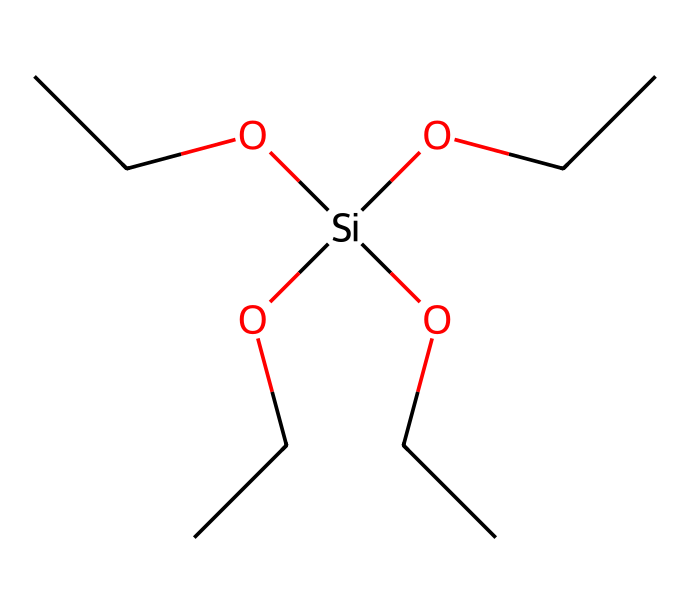What is the molecular formula of tetraethoxysilane? The molecular formula can be determined by counting the number of each type of atom present in the chemical structure. In the SMILES representation, there are 8 carbon atoms (C), 20 hydrogen atoms (H), 4 oxygen atoms (O), and 1 silicon atom (Si). This results in the formula C8H20O4Si.
Answer: C8H20O4Si How many ethoxy groups are present in tetraethoxysilane? The chemical structure shows that there are four ethoxy groups (–OCC) attached to the silicon atom. Each ethoxy group consists of two carbon atoms, so we confirm that there are four of them associated with the silicon.
Answer: 4 What functional groups are present in tetraethoxysilane? In the chemical structure, the prominent functional groups are the ethoxy groups (–OCC) and the silanol group, indicated by the presence of the silicon atom bonded to oxygen. The presence of oxygen atoms in these groups identifies them as functional groups.
Answer: ethoxy, silanol What is the primary element that characterizes silanes? Silanes are defined by the presence of silicon atoms, which are central to their structure. The Silicon atom’s connectivity to organic groups (like the ethoxy in this case) is key to classifying a compound as a silane.
Answer: silicon How many hydrogen atoms are bonded to the silicon in tetraethoxysilane? In the given structure, all four ethoxy groups are attached to the silicon atom, meaning it has no hydrogen atoms directly bonded to it. The compounds attached account for all valences filled. Thus, there are no hydrogen atoms directly bonded to the silicon.
Answer: 0 What distinguishes tetraethoxysilane from other silanes regarding its solubility? Tetraethoxysilane has ethoxy groups, which are hydrophilic in nature. This characteristic makes it more soluble in organic solvents compared to silanes that consist mostly of hydrophobic groups, enhancing its utility in applications such as waterproofing.
Answer: higher solubility 